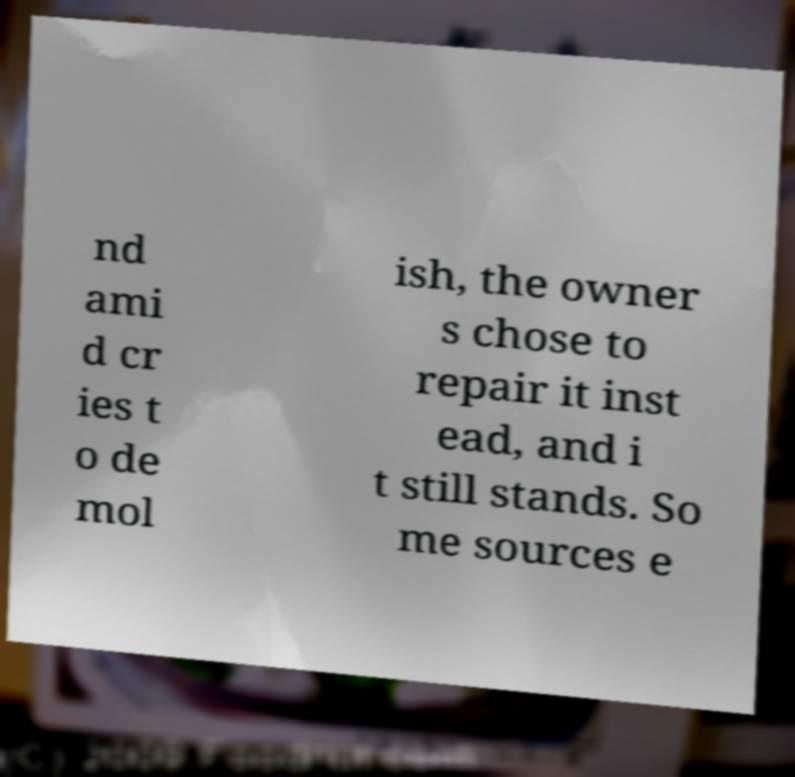Could you extract and type out the text from this image? nd ami d cr ies t o de mol ish, the owner s chose to repair it inst ead, and i t still stands. So me sources e 